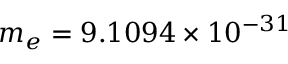Convert formula to latex. <formula><loc_0><loc_0><loc_500><loc_500>m _ { e } = 9 . 1 0 9 4 \times 1 0 ^ { - 3 1 }</formula> 